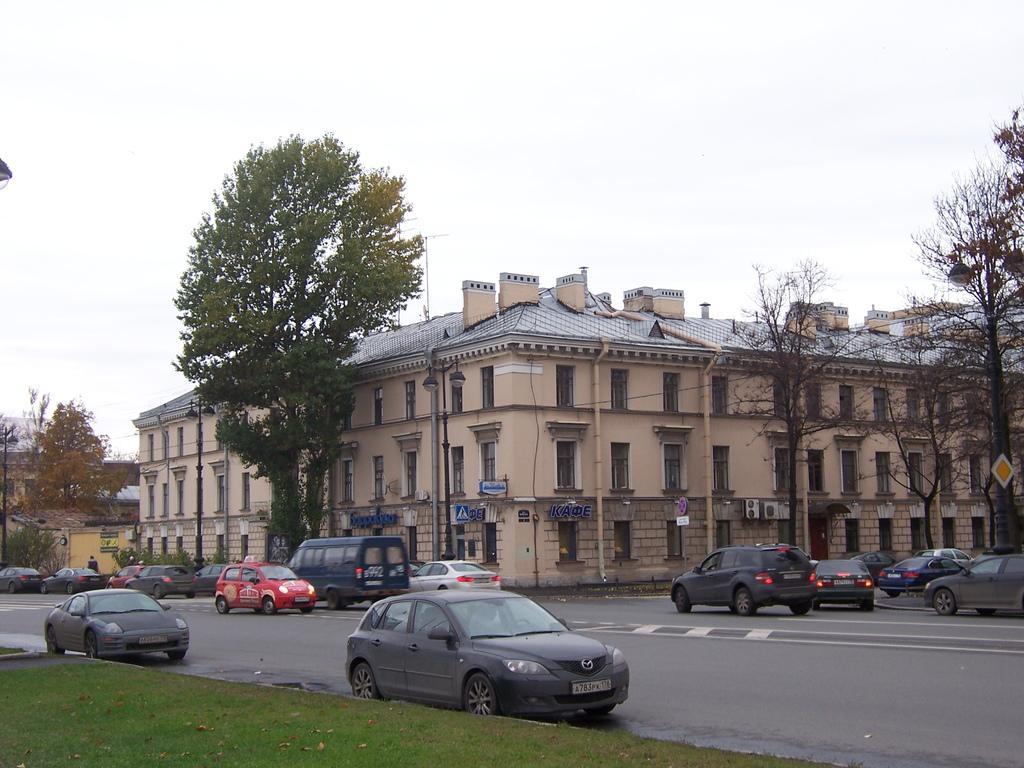In one or two sentences, can you explain what this image depicts? In the image in the center we can see few vehicles on the road. In the background we can see the sky,clouds,buildings,windows,poles,trees,sign board and grass. 